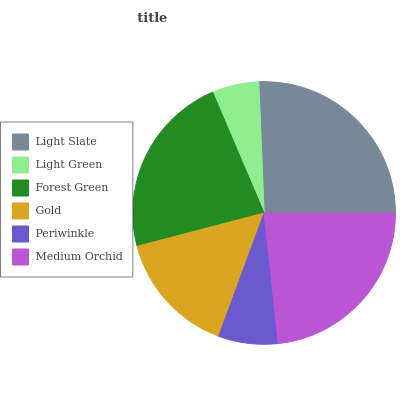Is Light Green the minimum?
Answer yes or no. Yes. Is Light Slate the maximum?
Answer yes or no. Yes. Is Forest Green the minimum?
Answer yes or no. No. Is Forest Green the maximum?
Answer yes or no. No. Is Forest Green greater than Light Green?
Answer yes or no. Yes. Is Light Green less than Forest Green?
Answer yes or no. Yes. Is Light Green greater than Forest Green?
Answer yes or no. No. Is Forest Green less than Light Green?
Answer yes or no. No. Is Forest Green the high median?
Answer yes or no. Yes. Is Gold the low median?
Answer yes or no. Yes. Is Gold the high median?
Answer yes or no. No. Is Light Green the low median?
Answer yes or no. No. 